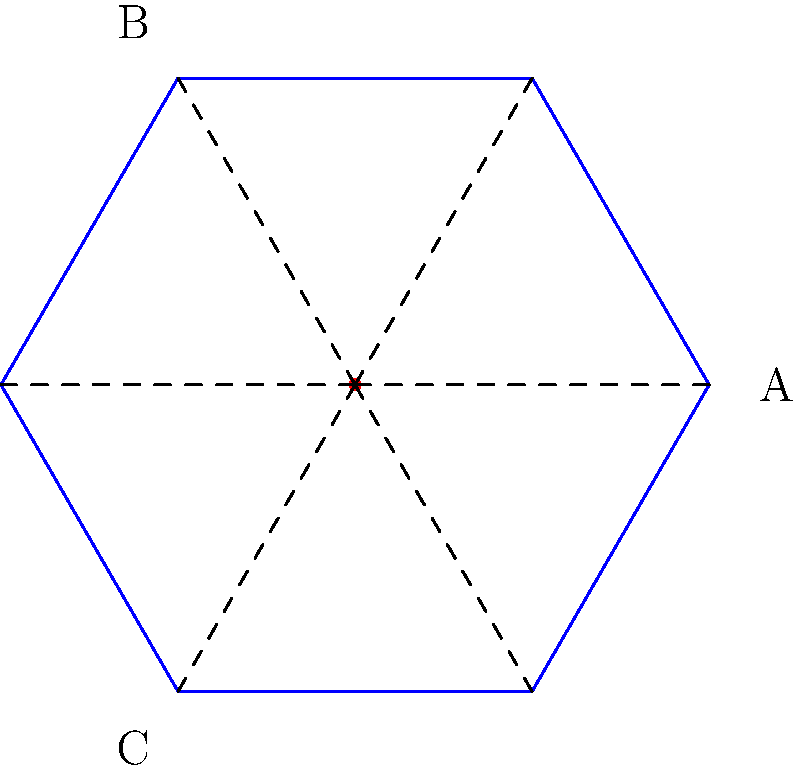Consider the snowflake-shaped water crystal shown above. What are the possible transformations that would map this snowflake onto itself, and how many lines of symmetry does it have? (Note: Understanding the symmetry of water molecules can help in comprehending how water behaves and interacts with contaminants.) To answer this question, let's analyze the snowflake's symmetry step-by-step:

1. Rotational symmetry:
   - The snowflake has 6 identical "arms" arranged around a central point.
   - It can be rotated by multiples of 60° (or $\frac{\pi}{3}$ radians) and still look the same.
   - This means it has 6-fold rotational symmetry.

2. Reflection symmetry:
   - There are 6 lines of symmetry passing through the center of the snowflake.
   - These lines bisect each arm and pass through the midpoint of the opposite side.

3. Transformations that map the snowflake onto itself:
   a) Identity transformation (no change)
   b) Rotations: 60°, 120°, 180°, 240°, 300°
   c) Reflections: across the 6 lines of symmetry

4. Total number of transformations:
   - 1 identity transformation
   - 5 rotations
   - 6 reflections
   - Total: 12 transformations

5. Number of lines of symmetry: 6

Understanding these symmetries is important because they reflect the molecular structure of water and ice, which influences how water interacts with other substances, including potential contaminants.
Answer: 12 transformations (1 identity, 5 rotations, 6 reflections) and 6 lines of symmetry 